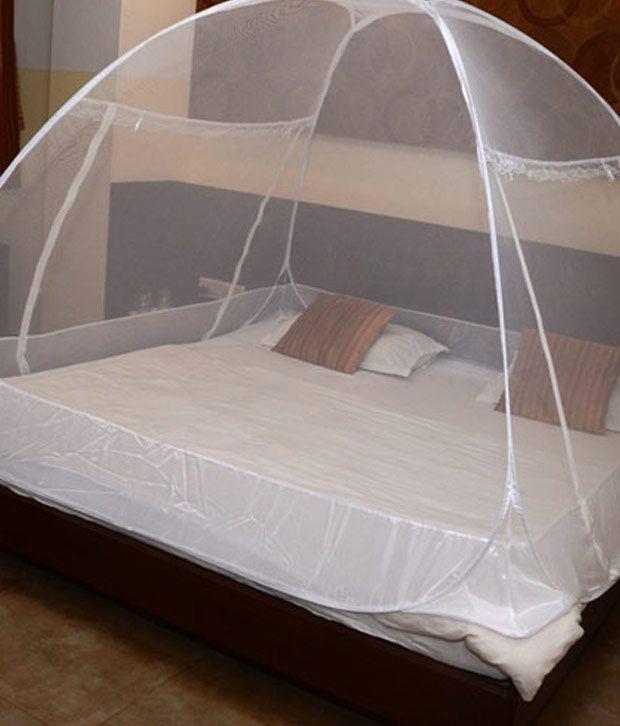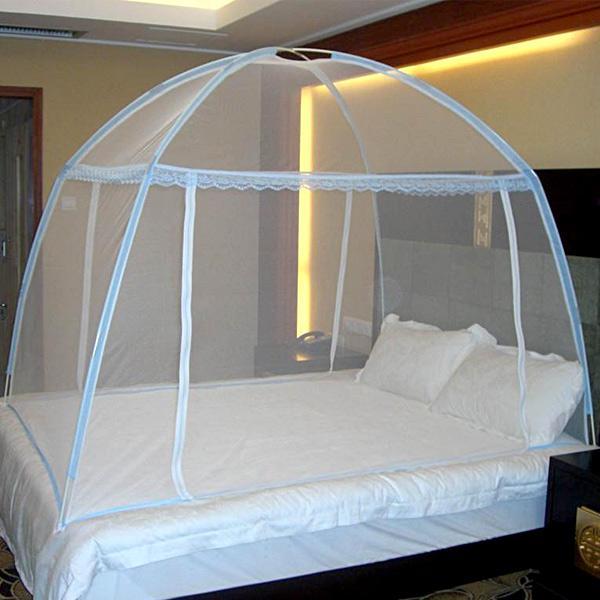The first image is the image on the left, the second image is the image on the right. For the images shown, is this caption "Both images show beds with the same shape of overhead drapery, but differing in construction detailing and in color." true? Answer yes or no. Yes. The first image is the image on the left, the second image is the image on the right. Analyze the images presented: Is the assertion "Both nets enclose the beds." valid? Answer yes or no. Yes. 